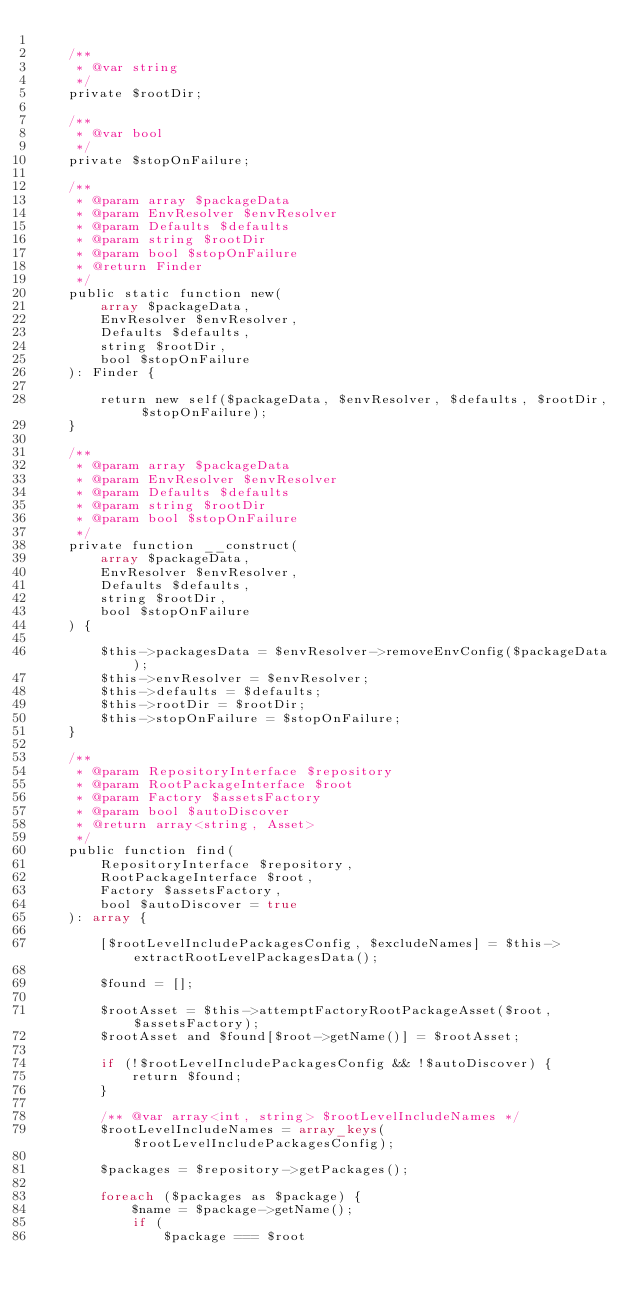Convert code to text. <code><loc_0><loc_0><loc_500><loc_500><_PHP_>
    /**
     * @var string
     */
    private $rootDir;

    /**
     * @var bool
     */
    private $stopOnFailure;

    /**
     * @param array $packageData
     * @param EnvResolver $envResolver
     * @param Defaults $defaults
     * @param string $rootDir
     * @param bool $stopOnFailure
     * @return Finder
     */
    public static function new(
        array $packageData,
        EnvResolver $envResolver,
        Defaults $defaults,
        string $rootDir,
        bool $stopOnFailure
    ): Finder {

        return new self($packageData, $envResolver, $defaults, $rootDir, $stopOnFailure);
    }

    /**
     * @param array $packageData
     * @param EnvResolver $envResolver
     * @param Defaults $defaults
     * @param string $rootDir
     * @param bool $stopOnFailure
     */
    private function __construct(
        array $packageData,
        EnvResolver $envResolver,
        Defaults $defaults,
        string $rootDir,
        bool $stopOnFailure
    ) {

        $this->packagesData = $envResolver->removeEnvConfig($packageData);
        $this->envResolver = $envResolver;
        $this->defaults = $defaults;
        $this->rootDir = $rootDir;
        $this->stopOnFailure = $stopOnFailure;
    }

    /**
     * @param RepositoryInterface $repository
     * @param RootPackageInterface $root
     * @param Factory $assetsFactory
     * @param bool $autoDiscover
     * @return array<string, Asset>
     */
    public function find(
        RepositoryInterface $repository,
        RootPackageInterface $root,
        Factory $assetsFactory,
        bool $autoDiscover = true
    ): array {

        [$rootLevelIncludePackagesConfig, $excludeNames] = $this->extractRootLevelPackagesData();

        $found = [];

        $rootAsset = $this->attemptFactoryRootPackageAsset($root, $assetsFactory);
        $rootAsset and $found[$root->getName()] = $rootAsset;

        if (!$rootLevelIncludePackagesConfig && !$autoDiscover) {
            return $found;
        }

        /** @var array<int, string> $rootLevelIncludeNames */
        $rootLevelIncludeNames = array_keys($rootLevelIncludePackagesConfig);

        $packages = $repository->getPackages();

        foreach ($packages as $package) {
            $name = $package->getName();
            if (
                $package === $root</code> 